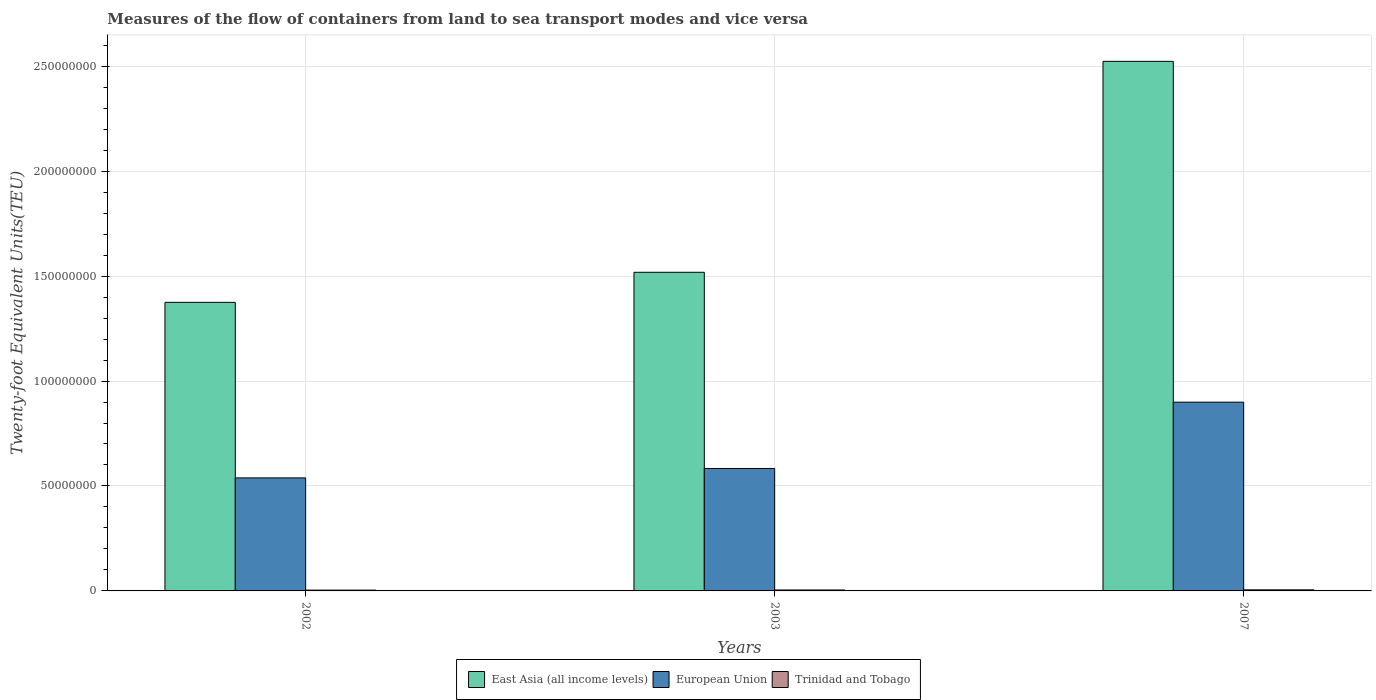How many different coloured bars are there?
Make the answer very short. 3. How many groups of bars are there?
Offer a very short reply. 3. Are the number of bars per tick equal to the number of legend labels?
Make the answer very short. Yes. How many bars are there on the 2nd tick from the left?
Offer a very short reply. 3. What is the label of the 2nd group of bars from the left?
Ensure brevity in your answer.  2003. What is the container port traffic in European Union in 2002?
Keep it short and to the point. 5.38e+07. Across all years, what is the maximum container port traffic in East Asia (all income levels)?
Provide a short and direct response. 2.52e+08. Across all years, what is the minimum container port traffic in Trinidad and Tobago?
Provide a short and direct response. 3.85e+05. In which year was the container port traffic in European Union maximum?
Your response must be concise. 2007. In which year was the container port traffic in European Union minimum?
Keep it short and to the point. 2002. What is the total container port traffic in East Asia (all income levels) in the graph?
Give a very brief answer. 5.42e+08. What is the difference between the container port traffic in Trinidad and Tobago in 2003 and that in 2007?
Ensure brevity in your answer.  -7.42e+04. What is the difference between the container port traffic in European Union in 2007 and the container port traffic in East Asia (all income levels) in 2003?
Your answer should be compact. -6.19e+07. What is the average container port traffic in East Asia (all income levels) per year?
Provide a short and direct response. 1.81e+08. In the year 2002, what is the difference between the container port traffic in European Union and container port traffic in East Asia (all income levels)?
Give a very brief answer. -8.36e+07. What is the ratio of the container port traffic in European Union in 2002 to that in 2007?
Your response must be concise. 0.6. Is the container port traffic in Trinidad and Tobago in 2002 less than that in 2003?
Make the answer very short. Yes. Is the difference between the container port traffic in European Union in 2002 and 2003 greater than the difference between the container port traffic in East Asia (all income levels) in 2002 and 2003?
Your answer should be very brief. Yes. What is the difference between the highest and the second highest container port traffic in Trinidad and Tobago?
Provide a short and direct response. 7.42e+04. What is the difference between the highest and the lowest container port traffic in European Union?
Keep it short and to the point. 3.61e+07. In how many years, is the container port traffic in European Union greater than the average container port traffic in European Union taken over all years?
Make the answer very short. 1. What does the 1st bar from the left in 2003 represents?
Give a very brief answer. East Asia (all income levels). What does the 1st bar from the right in 2003 represents?
Make the answer very short. Trinidad and Tobago. Is it the case that in every year, the sum of the container port traffic in European Union and container port traffic in Trinidad and Tobago is greater than the container port traffic in East Asia (all income levels)?
Ensure brevity in your answer.  No. How many bars are there?
Ensure brevity in your answer.  9. How many years are there in the graph?
Offer a very short reply. 3. Are the values on the major ticks of Y-axis written in scientific E-notation?
Keep it short and to the point. No. Does the graph contain any zero values?
Provide a succinct answer. No. Where does the legend appear in the graph?
Offer a terse response. Bottom center. How many legend labels are there?
Offer a terse response. 3. How are the legend labels stacked?
Your response must be concise. Horizontal. What is the title of the graph?
Offer a terse response. Measures of the flow of containers from land to sea transport modes and vice versa. Does "Swaziland" appear as one of the legend labels in the graph?
Your response must be concise. No. What is the label or title of the X-axis?
Your response must be concise. Years. What is the label or title of the Y-axis?
Ensure brevity in your answer.  Twenty-foot Equivalent Units(TEU). What is the Twenty-foot Equivalent Units(TEU) in East Asia (all income levels) in 2002?
Keep it short and to the point. 1.37e+08. What is the Twenty-foot Equivalent Units(TEU) in European Union in 2002?
Your answer should be very brief. 5.38e+07. What is the Twenty-foot Equivalent Units(TEU) of Trinidad and Tobago in 2002?
Your response must be concise. 3.85e+05. What is the Twenty-foot Equivalent Units(TEU) of East Asia (all income levels) in 2003?
Make the answer very short. 1.52e+08. What is the Twenty-foot Equivalent Units(TEU) in European Union in 2003?
Make the answer very short. 5.83e+07. What is the Twenty-foot Equivalent Units(TEU) of Trinidad and Tobago in 2003?
Your response must be concise. 4.40e+05. What is the Twenty-foot Equivalent Units(TEU) of East Asia (all income levels) in 2007?
Provide a succinct answer. 2.52e+08. What is the Twenty-foot Equivalent Units(TEU) of European Union in 2007?
Ensure brevity in your answer.  8.99e+07. What is the Twenty-foot Equivalent Units(TEU) in Trinidad and Tobago in 2007?
Give a very brief answer. 5.15e+05. Across all years, what is the maximum Twenty-foot Equivalent Units(TEU) in East Asia (all income levels)?
Keep it short and to the point. 2.52e+08. Across all years, what is the maximum Twenty-foot Equivalent Units(TEU) of European Union?
Keep it short and to the point. 8.99e+07. Across all years, what is the maximum Twenty-foot Equivalent Units(TEU) in Trinidad and Tobago?
Make the answer very short. 5.15e+05. Across all years, what is the minimum Twenty-foot Equivalent Units(TEU) in East Asia (all income levels)?
Ensure brevity in your answer.  1.37e+08. Across all years, what is the minimum Twenty-foot Equivalent Units(TEU) of European Union?
Ensure brevity in your answer.  5.38e+07. Across all years, what is the minimum Twenty-foot Equivalent Units(TEU) in Trinidad and Tobago?
Your response must be concise. 3.85e+05. What is the total Twenty-foot Equivalent Units(TEU) of East Asia (all income levels) in the graph?
Ensure brevity in your answer.  5.42e+08. What is the total Twenty-foot Equivalent Units(TEU) in European Union in the graph?
Your response must be concise. 2.02e+08. What is the total Twenty-foot Equivalent Units(TEU) in Trinidad and Tobago in the graph?
Offer a terse response. 1.34e+06. What is the difference between the Twenty-foot Equivalent Units(TEU) in East Asia (all income levels) in 2002 and that in 2003?
Provide a succinct answer. -1.43e+07. What is the difference between the Twenty-foot Equivalent Units(TEU) in European Union in 2002 and that in 2003?
Keep it short and to the point. -4.49e+06. What is the difference between the Twenty-foot Equivalent Units(TEU) of Trinidad and Tobago in 2002 and that in 2003?
Keep it short and to the point. -5.51e+04. What is the difference between the Twenty-foot Equivalent Units(TEU) of East Asia (all income levels) in 2002 and that in 2007?
Offer a terse response. -1.15e+08. What is the difference between the Twenty-foot Equivalent Units(TEU) of European Union in 2002 and that in 2007?
Offer a terse response. -3.61e+07. What is the difference between the Twenty-foot Equivalent Units(TEU) of Trinidad and Tobago in 2002 and that in 2007?
Offer a very short reply. -1.29e+05. What is the difference between the Twenty-foot Equivalent Units(TEU) in East Asia (all income levels) in 2003 and that in 2007?
Your answer should be very brief. -1.00e+08. What is the difference between the Twenty-foot Equivalent Units(TEU) in European Union in 2003 and that in 2007?
Provide a short and direct response. -3.16e+07. What is the difference between the Twenty-foot Equivalent Units(TEU) in Trinidad and Tobago in 2003 and that in 2007?
Ensure brevity in your answer.  -7.42e+04. What is the difference between the Twenty-foot Equivalent Units(TEU) of East Asia (all income levels) in 2002 and the Twenty-foot Equivalent Units(TEU) of European Union in 2003?
Offer a very short reply. 7.91e+07. What is the difference between the Twenty-foot Equivalent Units(TEU) of East Asia (all income levels) in 2002 and the Twenty-foot Equivalent Units(TEU) of Trinidad and Tobago in 2003?
Your answer should be compact. 1.37e+08. What is the difference between the Twenty-foot Equivalent Units(TEU) in European Union in 2002 and the Twenty-foot Equivalent Units(TEU) in Trinidad and Tobago in 2003?
Your response must be concise. 5.34e+07. What is the difference between the Twenty-foot Equivalent Units(TEU) of East Asia (all income levels) in 2002 and the Twenty-foot Equivalent Units(TEU) of European Union in 2007?
Offer a terse response. 4.76e+07. What is the difference between the Twenty-foot Equivalent Units(TEU) in East Asia (all income levels) in 2002 and the Twenty-foot Equivalent Units(TEU) in Trinidad and Tobago in 2007?
Offer a terse response. 1.37e+08. What is the difference between the Twenty-foot Equivalent Units(TEU) of European Union in 2002 and the Twenty-foot Equivalent Units(TEU) of Trinidad and Tobago in 2007?
Give a very brief answer. 5.33e+07. What is the difference between the Twenty-foot Equivalent Units(TEU) of East Asia (all income levels) in 2003 and the Twenty-foot Equivalent Units(TEU) of European Union in 2007?
Make the answer very short. 6.19e+07. What is the difference between the Twenty-foot Equivalent Units(TEU) of East Asia (all income levels) in 2003 and the Twenty-foot Equivalent Units(TEU) of Trinidad and Tobago in 2007?
Offer a very short reply. 1.51e+08. What is the difference between the Twenty-foot Equivalent Units(TEU) of European Union in 2003 and the Twenty-foot Equivalent Units(TEU) of Trinidad and Tobago in 2007?
Give a very brief answer. 5.78e+07. What is the average Twenty-foot Equivalent Units(TEU) in East Asia (all income levels) per year?
Give a very brief answer. 1.81e+08. What is the average Twenty-foot Equivalent Units(TEU) of European Union per year?
Offer a very short reply. 6.74e+07. What is the average Twenty-foot Equivalent Units(TEU) of Trinidad and Tobago per year?
Offer a terse response. 4.47e+05. In the year 2002, what is the difference between the Twenty-foot Equivalent Units(TEU) of East Asia (all income levels) and Twenty-foot Equivalent Units(TEU) of European Union?
Keep it short and to the point. 8.36e+07. In the year 2002, what is the difference between the Twenty-foot Equivalent Units(TEU) of East Asia (all income levels) and Twenty-foot Equivalent Units(TEU) of Trinidad and Tobago?
Make the answer very short. 1.37e+08. In the year 2002, what is the difference between the Twenty-foot Equivalent Units(TEU) in European Union and Twenty-foot Equivalent Units(TEU) in Trinidad and Tobago?
Ensure brevity in your answer.  5.35e+07. In the year 2003, what is the difference between the Twenty-foot Equivalent Units(TEU) in East Asia (all income levels) and Twenty-foot Equivalent Units(TEU) in European Union?
Provide a short and direct response. 9.35e+07. In the year 2003, what is the difference between the Twenty-foot Equivalent Units(TEU) in East Asia (all income levels) and Twenty-foot Equivalent Units(TEU) in Trinidad and Tobago?
Offer a terse response. 1.51e+08. In the year 2003, what is the difference between the Twenty-foot Equivalent Units(TEU) of European Union and Twenty-foot Equivalent Units(TEU) of Trinidad and Tobago?
Your answer should be very brief. 5.79e+07. In the year 2007, what is the difference between the Twenty-foot Equivalent Units(TEU) in East Asia (all income levels) and Twenty-foot Equivalent Units(TEU) in European Union?
Your answer should be compact. 1.62e+08. In the year 2007, what is the difference between the Twenty-foot Equivalent Units(TEU) in East Asia (all income levels) and Twenty-foot Equivalent Units(TEU) in Trinidad and Tobago?
Your answer should be very brief. 2.52e+08. In the year 2007, what is the difference between the Twenty-foot Equivalent Units(TEU) in European Union and Twenty-foot Equivalent Units(TEU) in Trinidad and Tobago?
Make the answer very short. 8.94e+07. What is the ratio of the Twenty-foot Equivalent Units(TEU) of East Asia (all income levels) in 2002 to that in 2003?
Provide a short and direct response. 0.91. What is the ratio of the Twenty-foot Equivalent Units(TEU) of European Union in 2002 to that in 2003?
Keep it short and to the point. 0.92. What is the ratio of the Twenty-foot Equivalent Units(TEU) in Trinidad and Tobago in 2002 to that in 2003?
Your response must be concise. 0.87. What is the ratio of the Twenty-foot Equivalent Units(TEU) of East Asia (all income levels) in 2002 to that in 2007?
Make the answer very short. 0.54. What is the ratio of the Twenty-foot Equivalent Units(TEU) in European Union in 2002 to that in 2007?
Offer a terse response. 0.6. What is the ratio of the Twenty-foot Equivalent Units(TEU) of Trinidad and Tobago in 2002 to that in 2007?
Keep it short and to the point. 0.75. What is the ratio of the Twenty-foot Equivalent Units(TEU) of East Asia (all income levels) in 2003 to that in 2007?
Provide a short and direct response. 0.6. What is the ratio of the Twenty-foot Equivalent Units(TEU) in European Union in 2003 to that in 2007?
Your answer should be very brief. 0.65. What is the ratio of the Twenty-foot Equivalent Units(TEU) in Trinidad and Tobago in 2003 to that in 2007?
Your answer should be very brief. 0.86. What is the difference between the highest and the second highest Twenty-foot Equivalent Units(TEU) in East Asia (all income levels)?
Your response must be concise. 1.00e+08. What is the difference between the highest and the second highest Twenty-foot Equivalent Units(TEU) in European Union?
Offer a very short reply. 3.16e+07. What is the difference between the highest and the second highest Twenty-foot Equivalent Units(TEU) in Trinidad and Tobago?
Ensure brevity in your answer.  7.42e+04. What is the difference between the highest and the lowest Twenty-foot Equivalent Units(TEU) of East Asia (all income levels)?
Ensure brevity in your answer.  1.15e+08. What is the difference between the highest and the lowest Twenty-foot Equivalent Units(TEU) in European Union?
Your response must be concise. 3.61e+07. What is the difference between the highest and the lowest Twenty-foot Equivalent Units(TEU) of Trinidad and Tobago?
Offer a very short reply. 1.29e+05. 